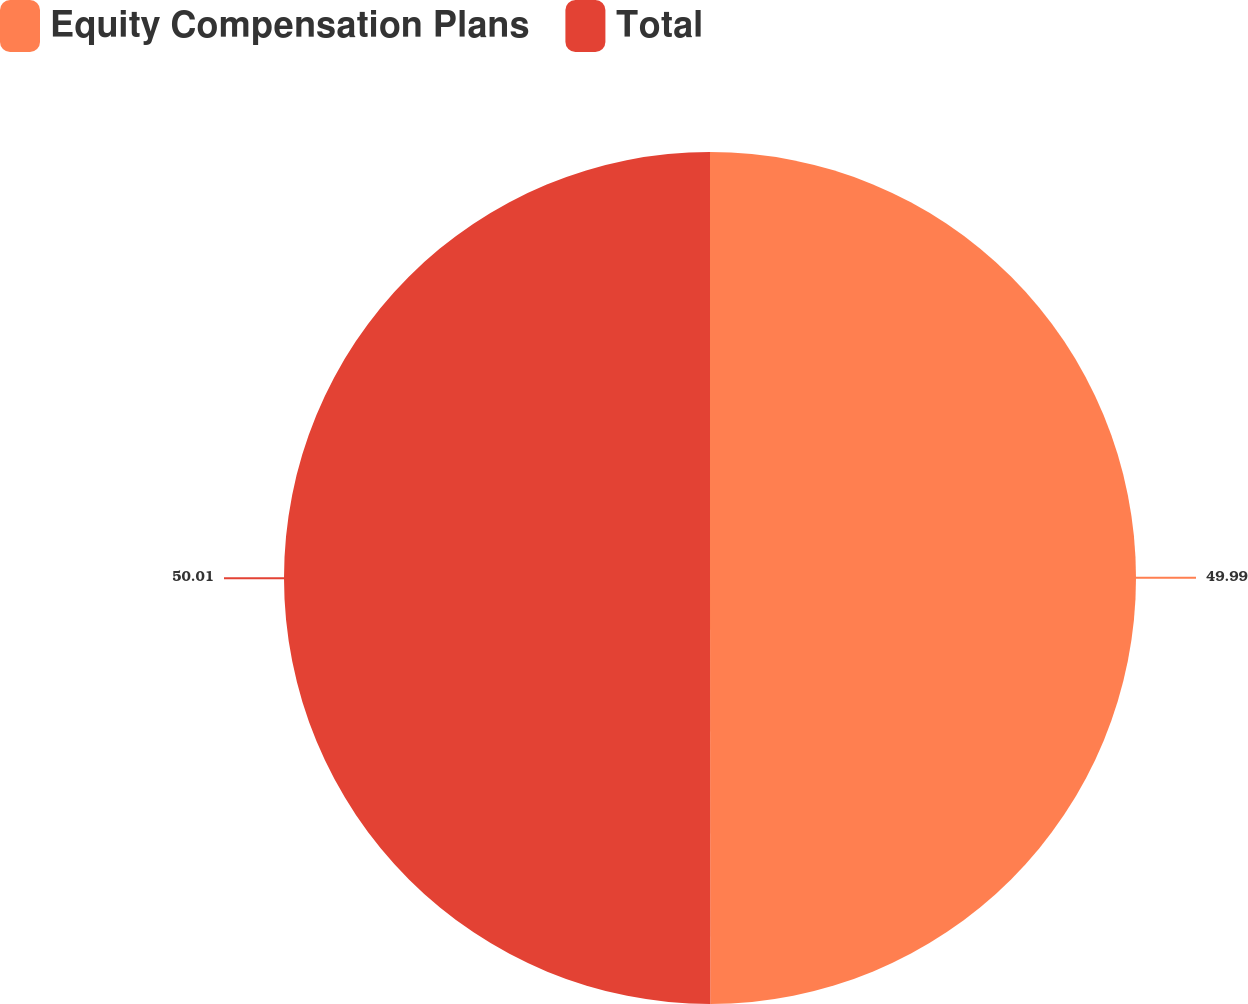Convert chart to OTSL. <chart><loc_0><loc_0><loc_500><loc_500><pie_chart><fcel>Equity Compensation Plans<fcel>Total<nl><fcel>49.99%<fcel>50.01%<nl></chart> 